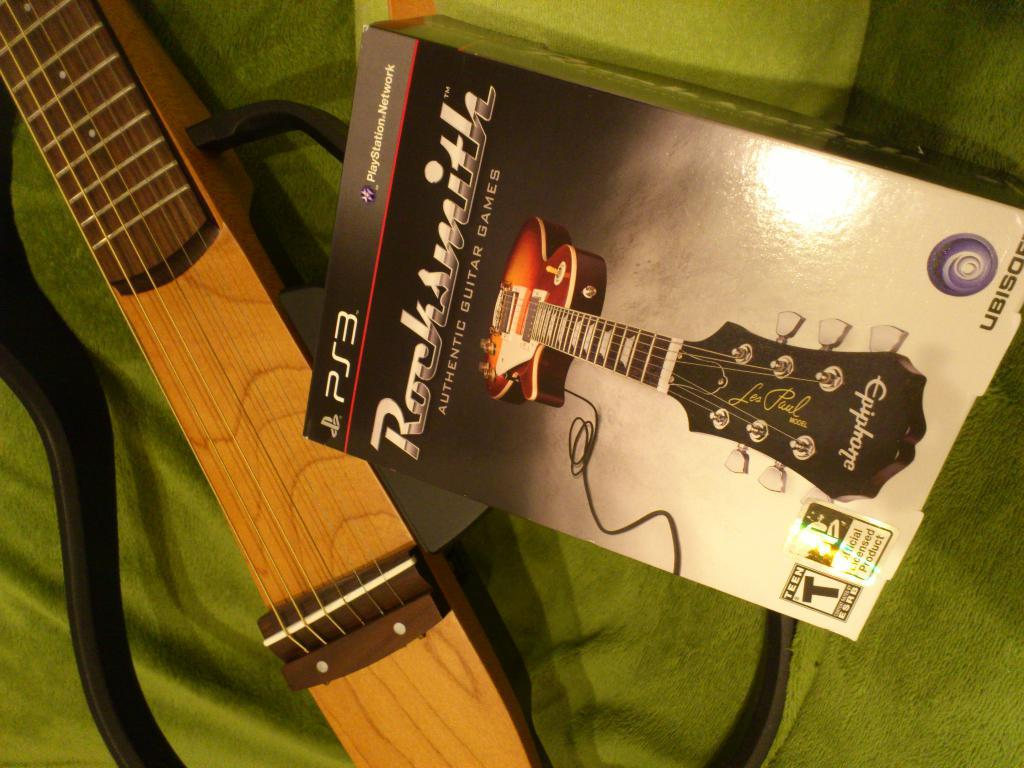<image>
Relay a brief, clear account of the picture shown. A guitar sits next to a Rocksmith's Authentic Guitar Games game for Playstation 3. 